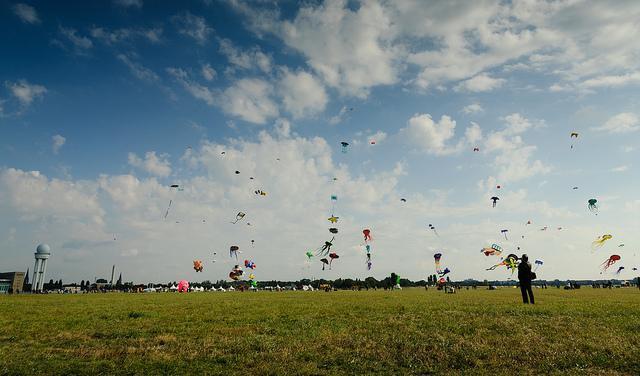How many people are visible in this image?
Give a very brief answer. 1. 